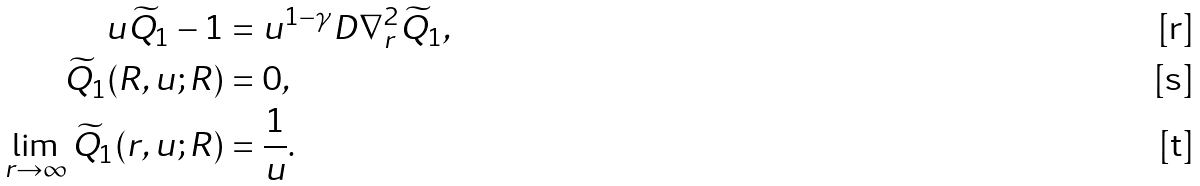Convert formula to latex. <formula><loc_0><loc_0><loc_500><loc_500>u \widetilde { Q } _ { 1 } - 1 & = u ^ { 1 - \gamma } D \nabla ^ { 2 } _ { r } \widetilde { Q } _ { 1 } , \\ \widetilde { Q } _ { 1 } ( R , u ; R ) & = 0 , \\ \lim _ { r \to \infty } \widetilde { Q } _ { 1 } ( r , u ; R ) & = \frac { 1 } { u } .</formula> 